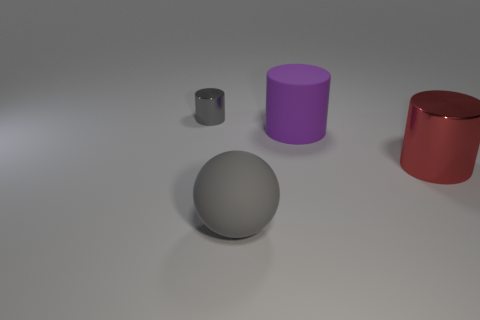Subtract all purple cylinders. Subtract all green balls. How many cylinders are left? 2 Add 2 large metal balls. How many objects exist? 6 Subtract all balls. How many objects are left? 3 Add 2 rubber cylinders. How many rubber cylinders are left? 3 Add 4 big spheres. How many big spheres exist? 5 Subtract 0 cyan blocks. How many objects are left? 4 Subtract all brown rubber things. Subtract all tiny gray cylinders. How many objects are left? 3 